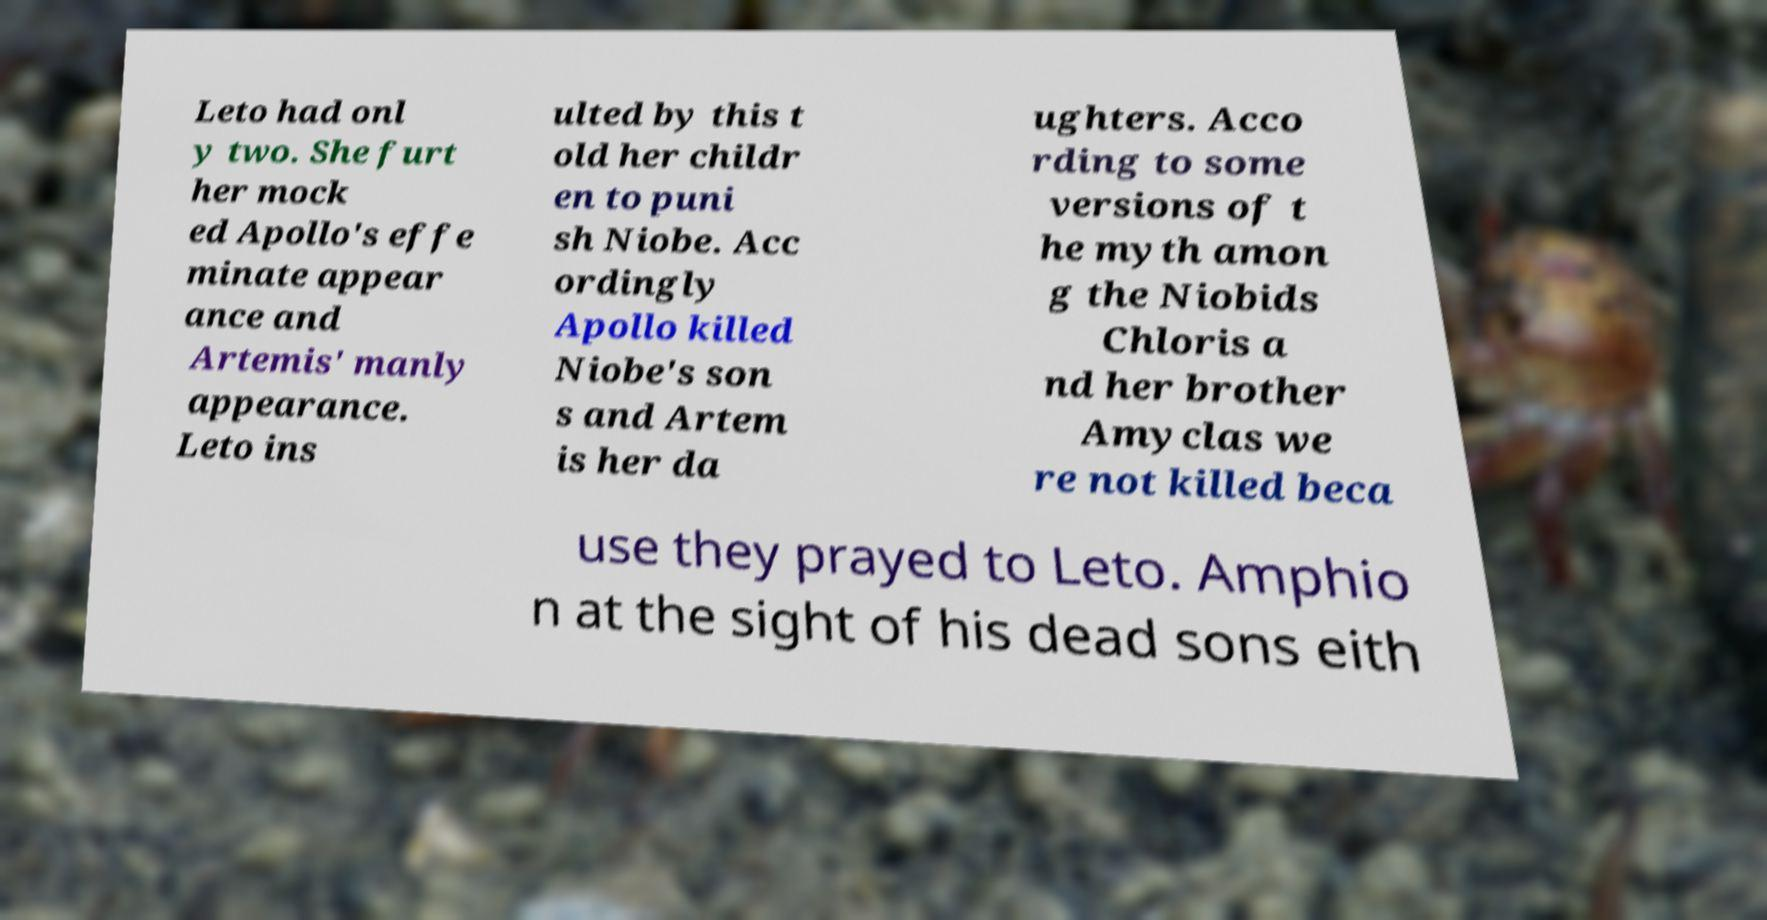Can you read and provide the text displayed in the image?This photo seems to have some interesting text. Can you extract and type it out for me? Leto had onl y two. She furt her mock ed Apollo's effe minate appear ance and Artemis' manly appearance. Leto ins ulted by this t old her childr en to puni sh Niobe. Acc ordingly Apollo killed Niobe's son s and Artem is her da ughters. Acco rding to some versions of t he myth amon g the Niobids Chloris a nd her brother Amyclas we re not killed beca use they prayed to Leto. Amphio n at the sight of his dead sons eith 